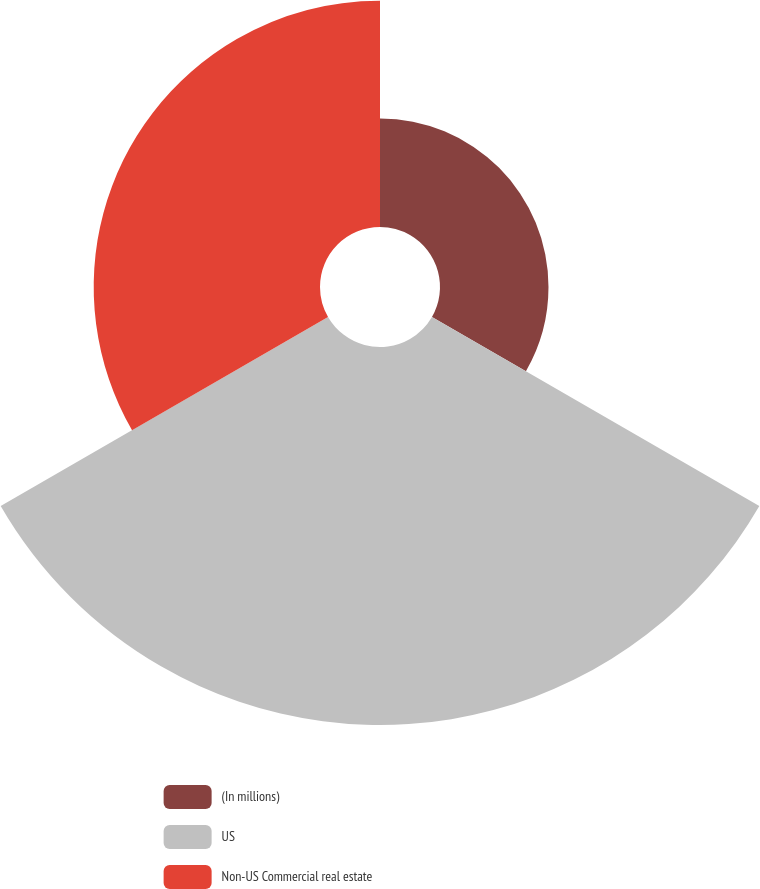Convert chart to OTSL. <chart><loc_0><loc_0><loc_500><loc_500><pie_chart><fcel>(In millions)<fcel>US<fcel>Non-US Commercial real estate<nl><fcel>15.22%<fcel>53.03%<fcel>31.75%<nl></chart> 